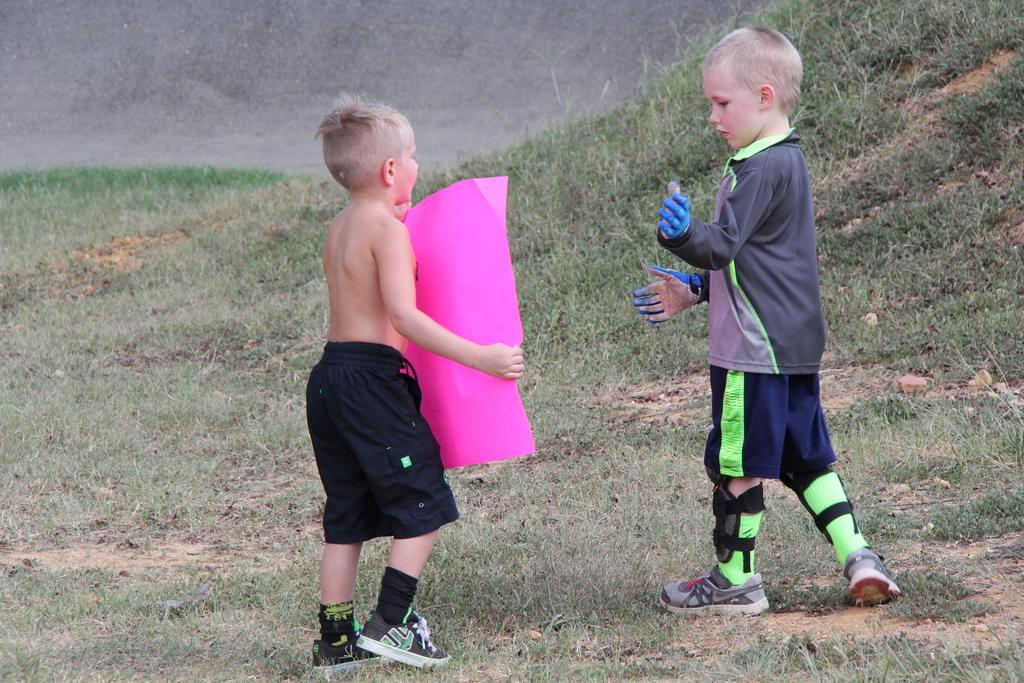What type of vegetation is present in the image? There is grass in the image. How many people are in the image? There are two boys in the image. What is the position of one of the boys? One of the boys is standing. What is the standing boy holding in his hand? The standing boy is holding a pink color sheet in his hand. Is there a coast visible in the image? No, there is no coast visible in the image. Can you see a stream running through the grass in the image? No, there is no stream visible in the image. 